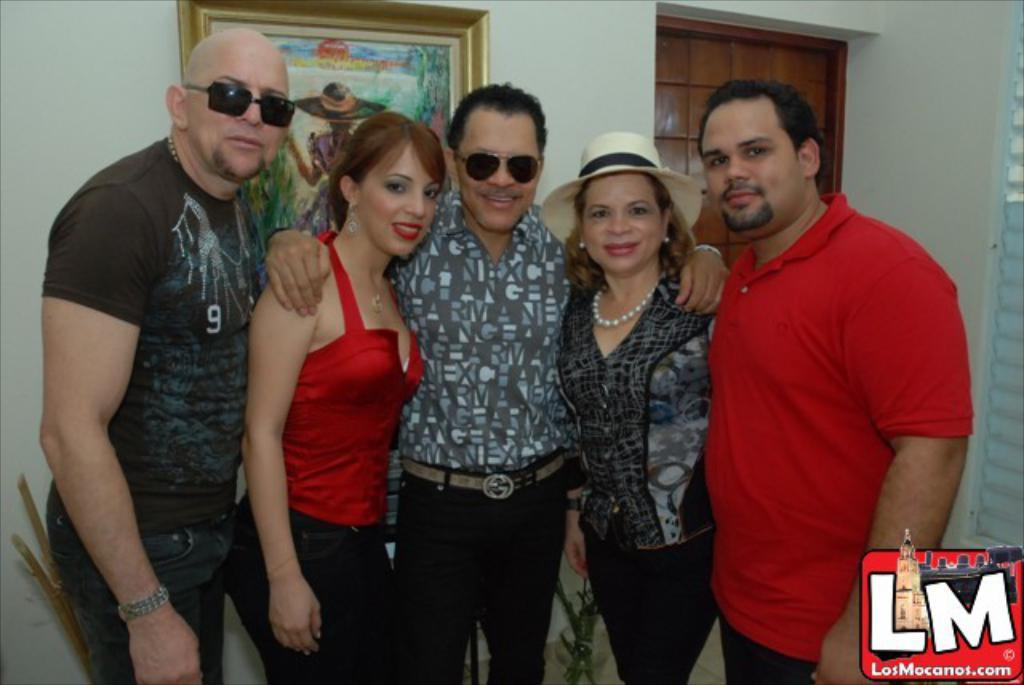What are the people in the image doing? The people in the image are standing and smiling. What can be seen on the floor in the image? The facts do not mention anything specific about the floor. What is visible in the background of the image? There is a window and a wall hanging attached to a wall in the background of the image. What type of profit did the people discover while standing in the image? There is no mention of profit or discovery in the image. The people are simply standing and smiling. 